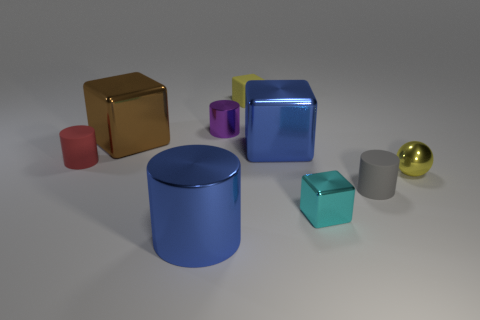Subtract 1 blocks. How many blocks are left? 3 Add 1 red matte things. How many objects exist? 10 Subtract all spheres. How many objects are left? 8 Subtract all small blue matte things. Subtract all blue metallic objects. How many objects are left? 7 Add 1 large blue shiny cylinders. How many large blue shiny cylinders are left? 2 Add 5 small purple shiny objects. How many small purple shiny objects exist? 6 Subtract 0 green blocks. How many objects are left? 9 